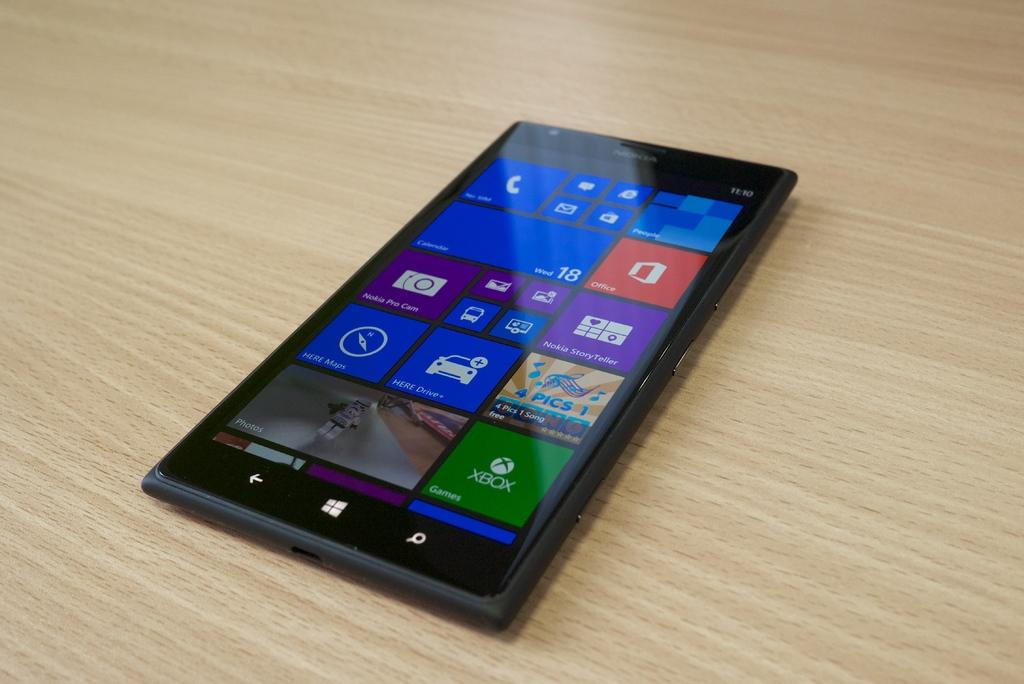Provide a one-sentence caption for the provided image. A Nokia cell phone has the time of 11:10 in the upper right hand corner. 